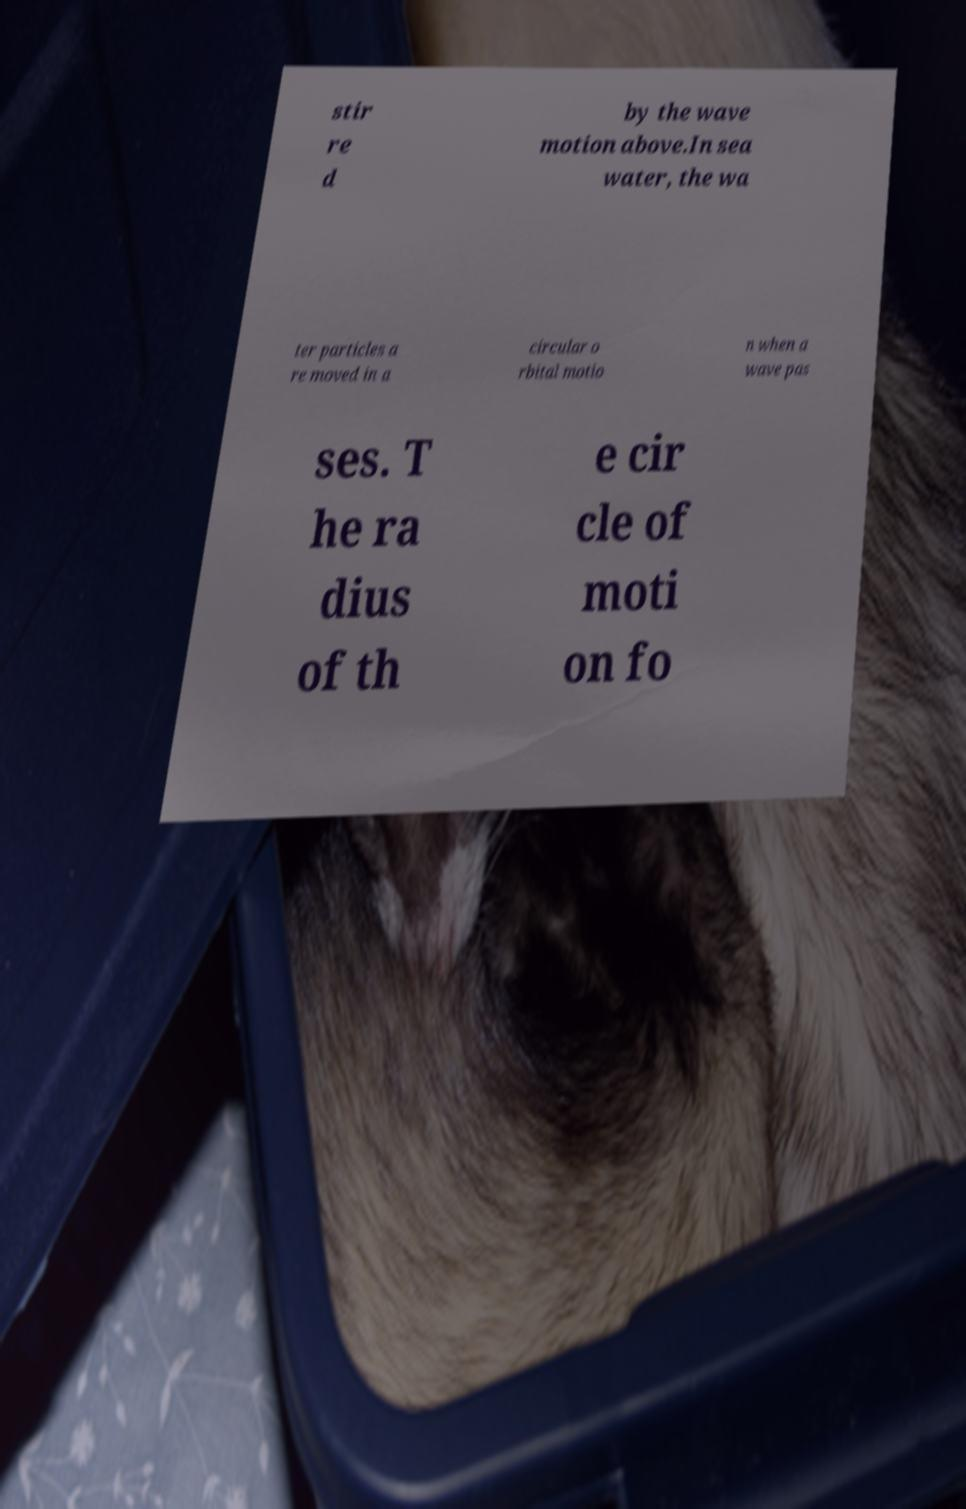Please identify and transcribe the text found in this image. stir re d by the wave motion above.In sea water, the wa ter particles a re moved in a circular o rbital motio n when a wave pas ses. T he ra dius of th e cir cle of moti on fo 